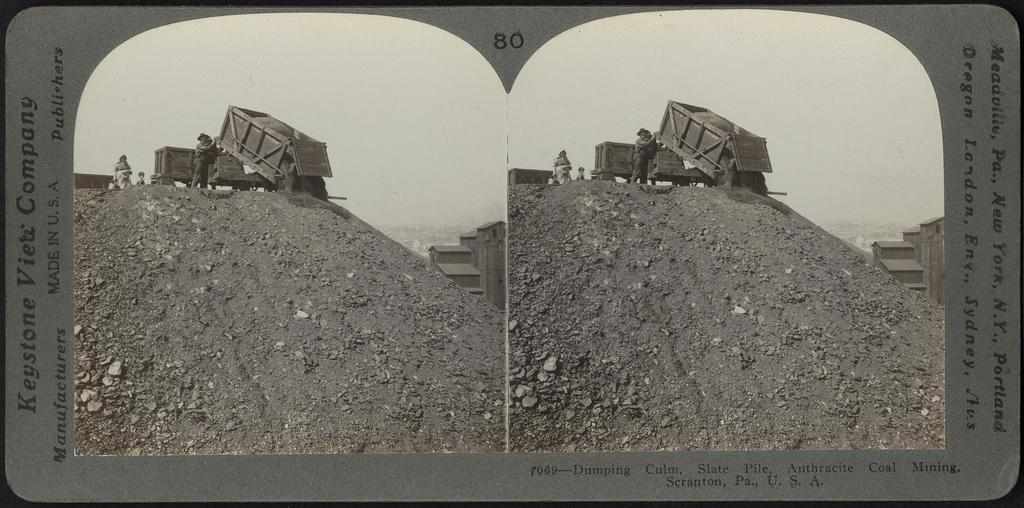Provide a one-sentence caption for the provided image. Keystone company picture of a dump truck showing a the truck at work. 